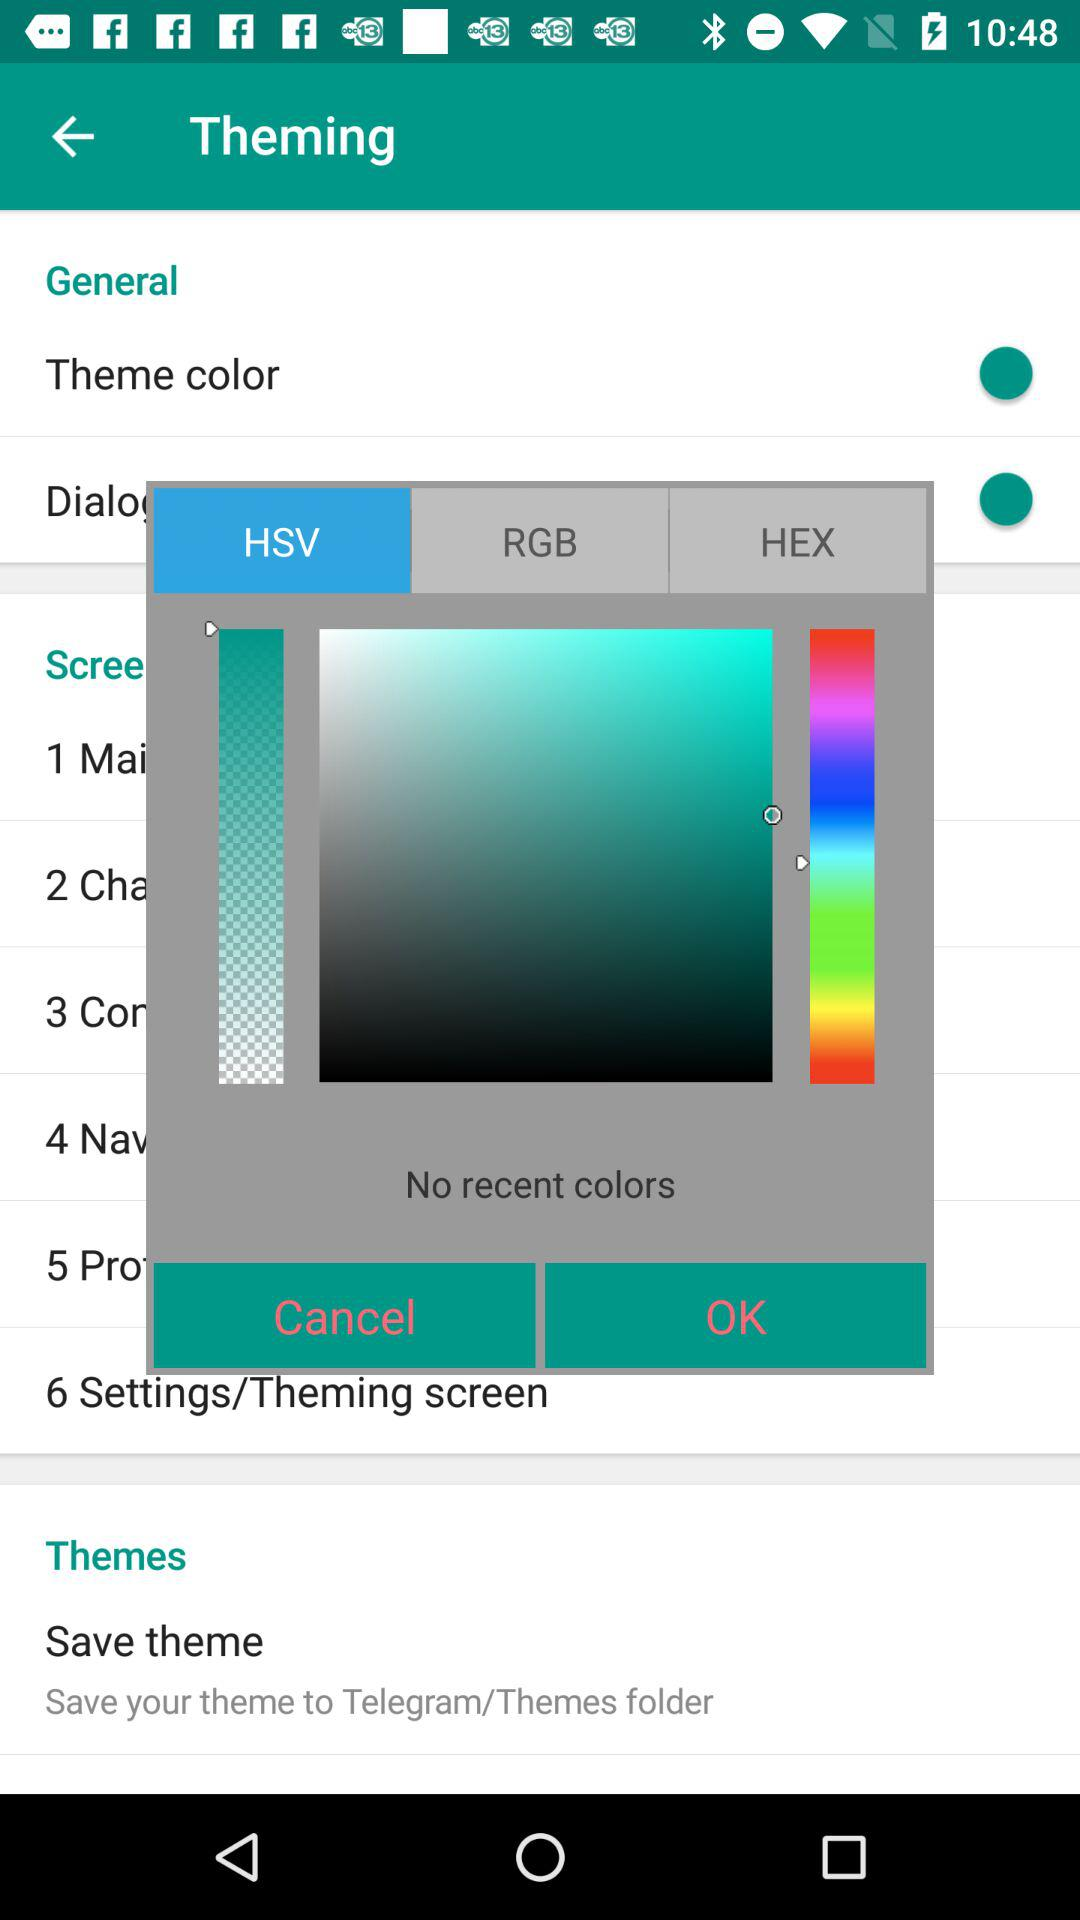How many color modes are there to choose from?
Answer the question using a single word or phrase. 3 